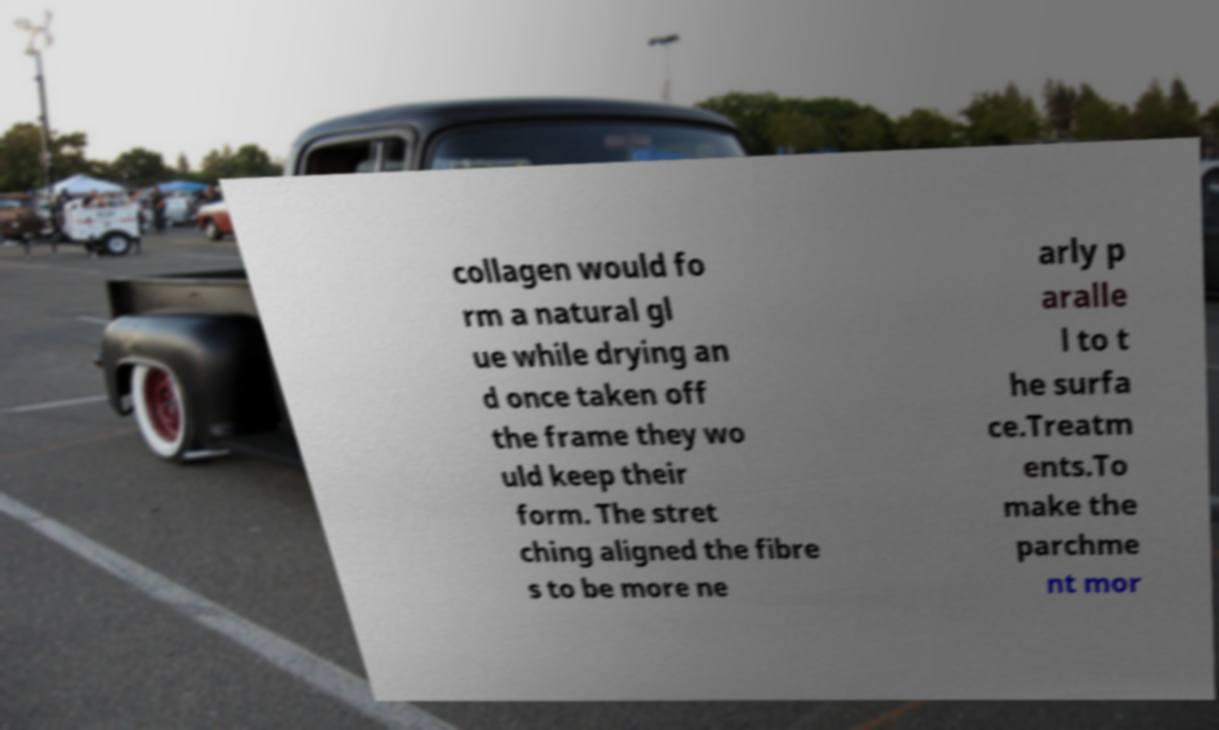Can you accurately transcribe the text from the provided image for me? collagen would fo rm a natural gl ue while drying an d once taken off the frame they wo uld keep their form. The stret ching aligned the fibre s to be more ne arly p aralle l to t he surfa ce.Treatm ents.To make the parchme nt mor 